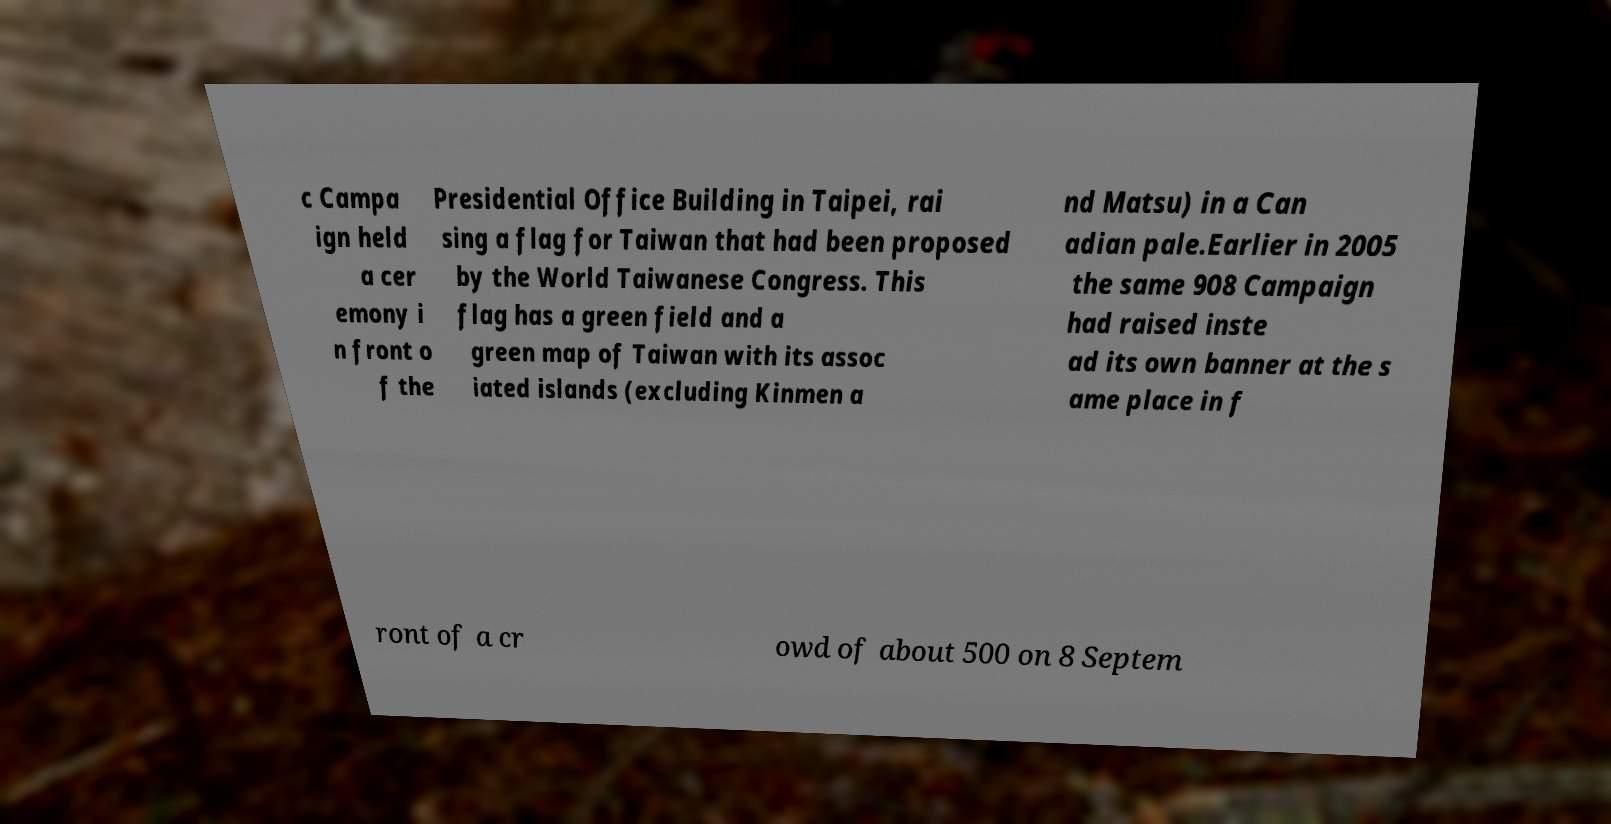What messages or text are displayed in this image? I need them in a readable, typed format. c Campa ign held a cer emony i n front o f the Presidential Office Building in Taipei, rai sing a flag for Taiwan that had been proposed by the World Taiwanese Congress. This flag has a green field and a green map of Taiwan with its assoc iated islands (excluding Kinmen a nd Matsu) in a Can adian pale.Earlier in 2005 the same 908 Campaign had raised inste ad its own banner at the s ame place in f ront of a cr owd of about 500 on 8 Septem 